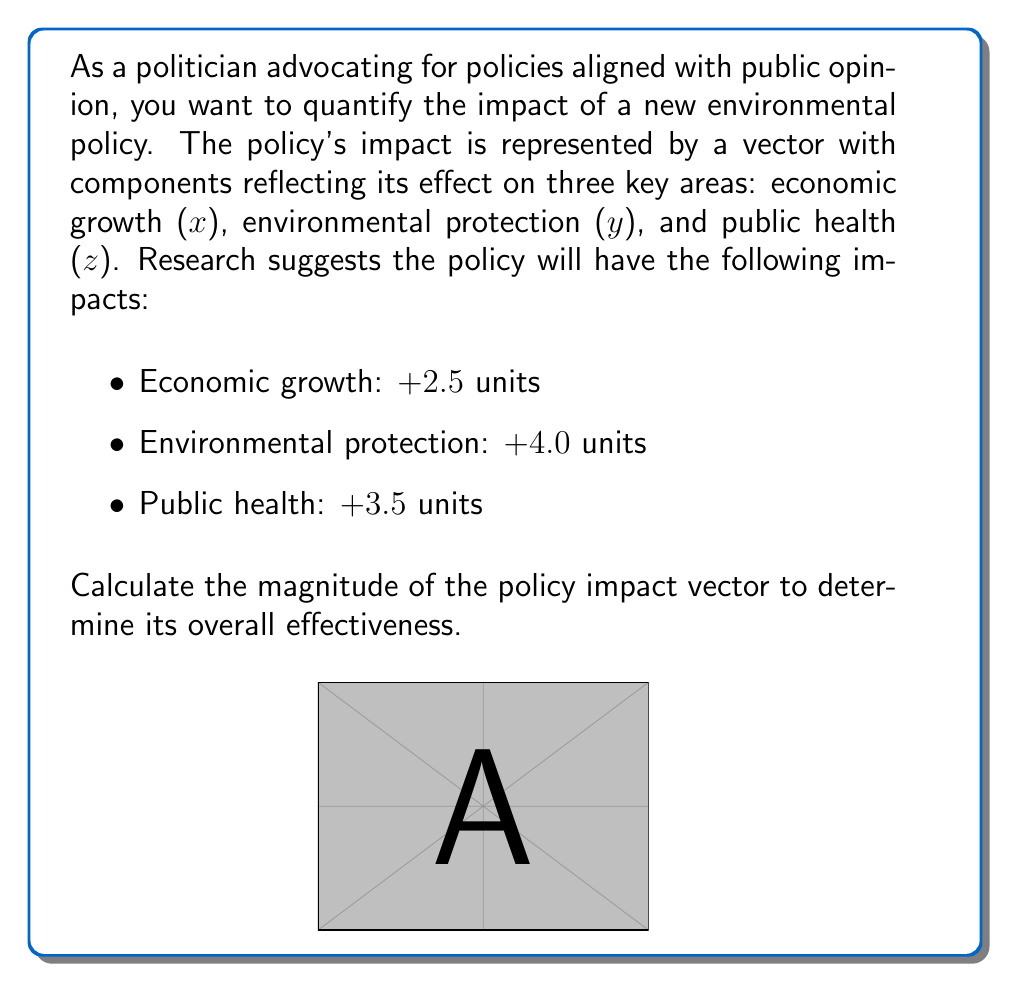Solve this math problem. To find the magnitude of the policy impact vector, we need to follow these steps:

1) First, let's define our vector. Given the information:
   $$\vec{v} = (2.5, 4.0, 3.5)$$

2) The magnitude of a vector in three-dimensional space is given by the formula:
   $$|\vec{v}| = \sqrt{x^2 + y^2 + z^2}$$

3) Let's substitute our values:
   $$|\vec{v}| = \sqrt{(2.5)^2 + (4.0)^2 + (3.5)^2}$$

4) Now, let's calculate each term inside the square root:
   $$|\vec{v}| = \sqrt{6.25 + 16.00 + 12.25}$$

5) Add these values:
   $$|\vec{v}| = \sqrt{34.50}$$

6) Finally, calculate the square root:
   $$|\vec{v}| = 5.87$$

Therefore, the magnitude of the policy impact vector is approximately 5.87 units.
Answer: $5.87$ units 